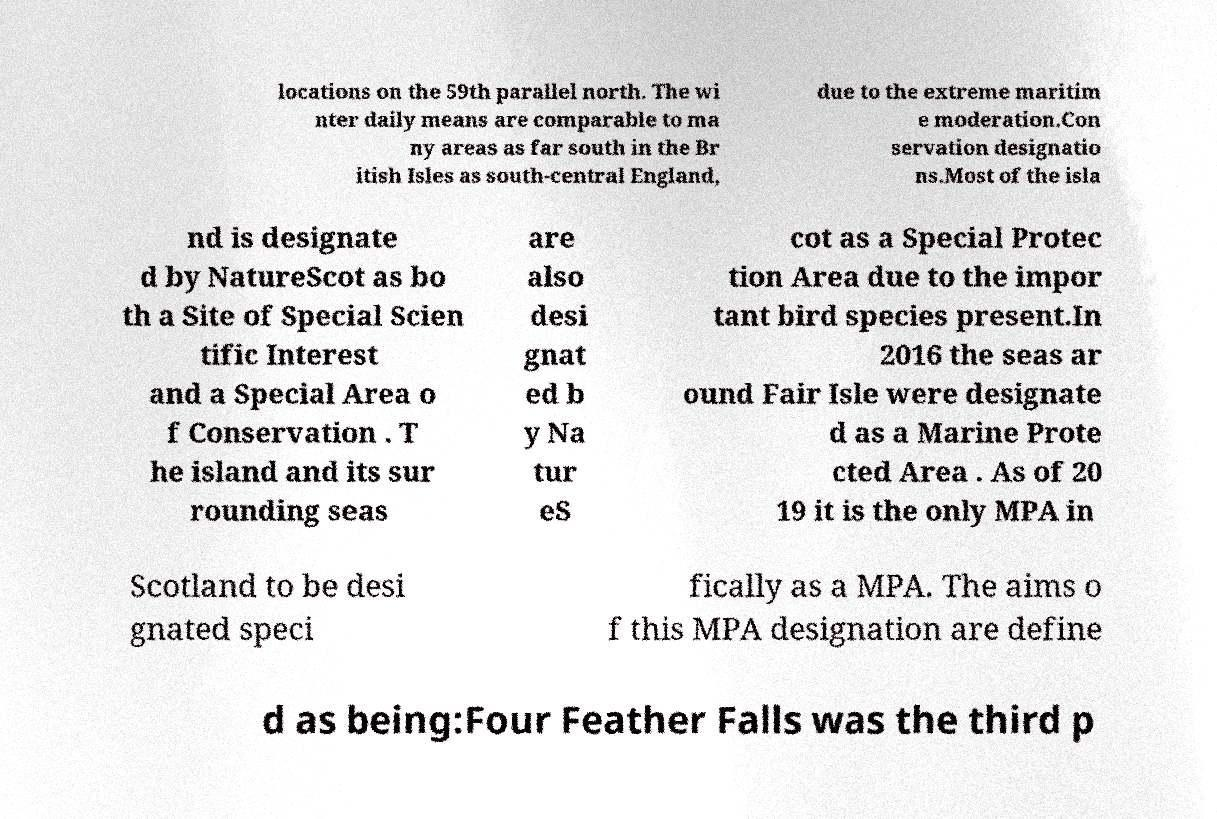Could you extract and type out the text from this image? locations on the 59th parallel north. The wi nter daily means are comparable to ma ny areas as far south in the Br itish Isles as south-central England, due to the extreme maritim e moderation.Con servation designatio ns.Most of the isla nd is designate d by NatureScot as bo th a Site of Special Scien tific Interest and a Special Area o f Conservation . T he island and its sur rounding seas are also desi gnat ed b y Na tur eS cot as a Special Protec tion Area due to the impor tant bird species present.In 2016 the seas ar ound Fair Isle were designate d as a Marine Prote cted Area . As of 20 19 it is the only MPA in Scotland to be desi gnated speci fically as a MPA. The aims o f this MPA designation are define d as being:Four Feather Falls was the third p 